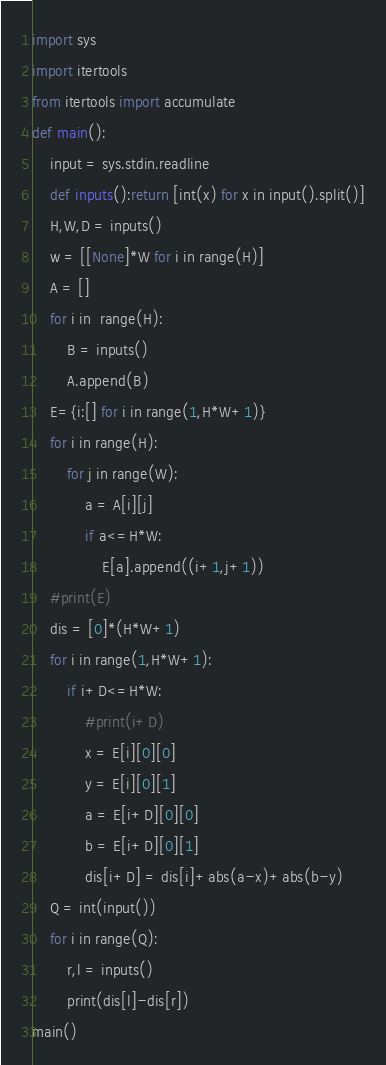<code> <loc_0><loc_0><loc_500><loc_500><_Python_>import sys
import itertools
from itertools import accumulate
def main():
    input = sys.stdin.readline
    def inputs():return [int(x) for x in input().split()]
    H,W,D = inputs()
    w = [[None]*W for i in range(H)]
    A = []
    for i in  range(H):
        B = inputs()
        A.append(B)
    E={i:[] for i in range(1,H*W+1)}
    for i in range(H):
        for j in range(W):
            a = A[i][j]
            if a<=H*W:
                E[a].append((i+1,j+1))
    #print(E)
    dis = [0]*(H*W+1)
    for i in range(1,H*W+1):
        if i+D<=H*W:
            #print(i+D)
            x = E[i][0][0]
            y = E[i][0][1]
            a = E[i+D][0][0]
            b = E[i+D][0][1]
            dis[i+D] = dis[i]+abs(a-x)+abs(b-y)
    Q = int(input())
    for i in range(Q):
        r,l = inputs()
        print(dis[l]-dis[r])
main()</code> 